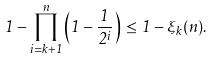<formula> <loc_0><loc_0><loc_500><loc_500>1 - \prod _ { i = k + 1 } ^ { n } \left ( 1 - \frac { 1 } { 2 ^ { i } } \right ) \, \leq \, 1 - \xi _ { k } ( n ) .</formula> 